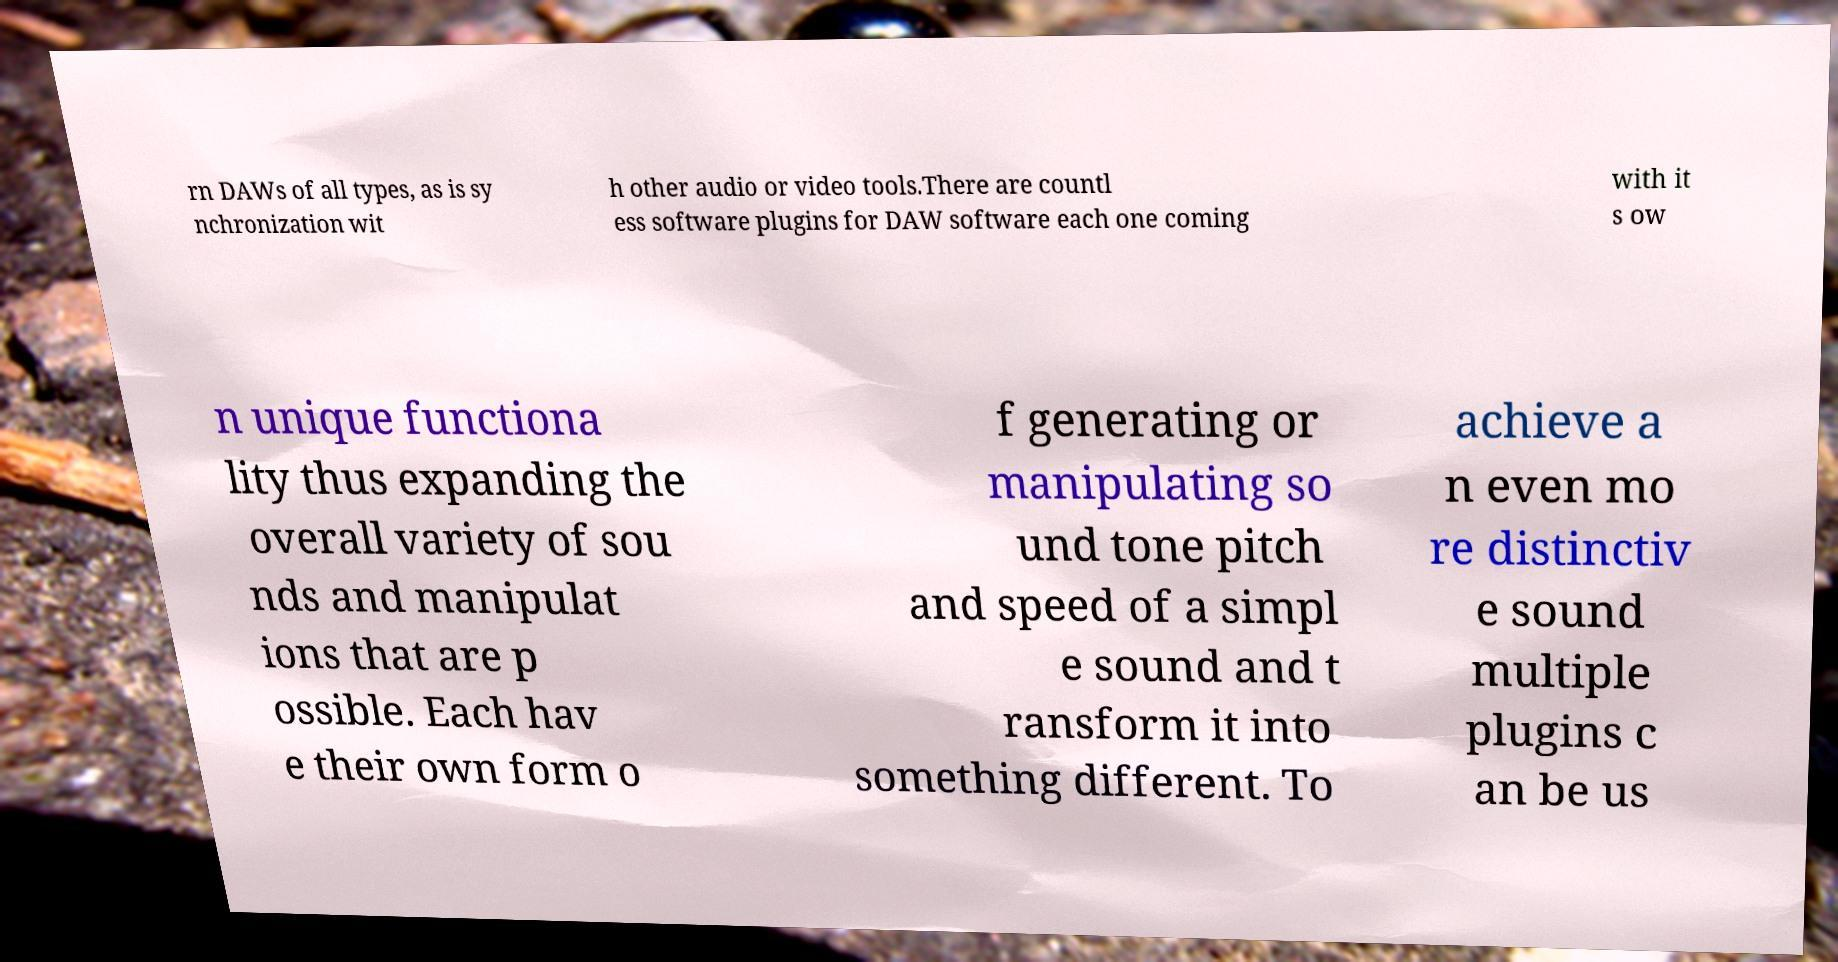There's text embedded in this image that I need extracted. Can you transcribe it verbatim? rn DAWs of all types, as is sy nchronization wit h other audio or video tools.There are countl ess software plugins for DAW software each one coming with it s ow n unique functiona lity thus expanding the overall variety of sou nds and manipulat ions that are p ossible. Each hav e their own form o f generating or manipulating so und tone pitch and speed of a simpl e sound and t ransform it into something different. To achieve a n even mo re distinctiv e sound multiple plugins c an be us 